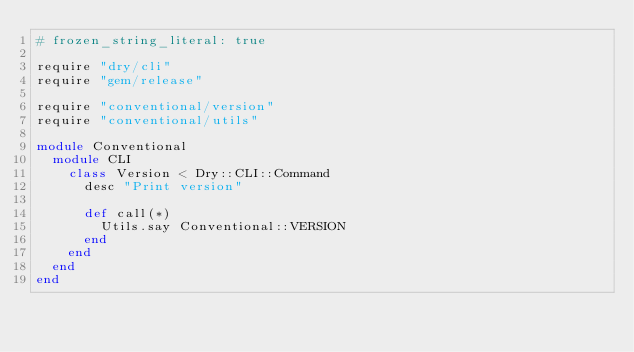Convert code to text. <code><loc_0><loc_0><loc_500><loc_500><_Ruby_># frozen_string_literal: true

require "dry/cli"
require "gem/release"

require "conventional/version"
require "conventional/utils"

module Conventional
  module CLI
    class Version < Dry::CLI::Command
      desc "Print version"

      def call(*)
        Utils.say Conventional::VERSION
      end
    end
  end
end
</code> 